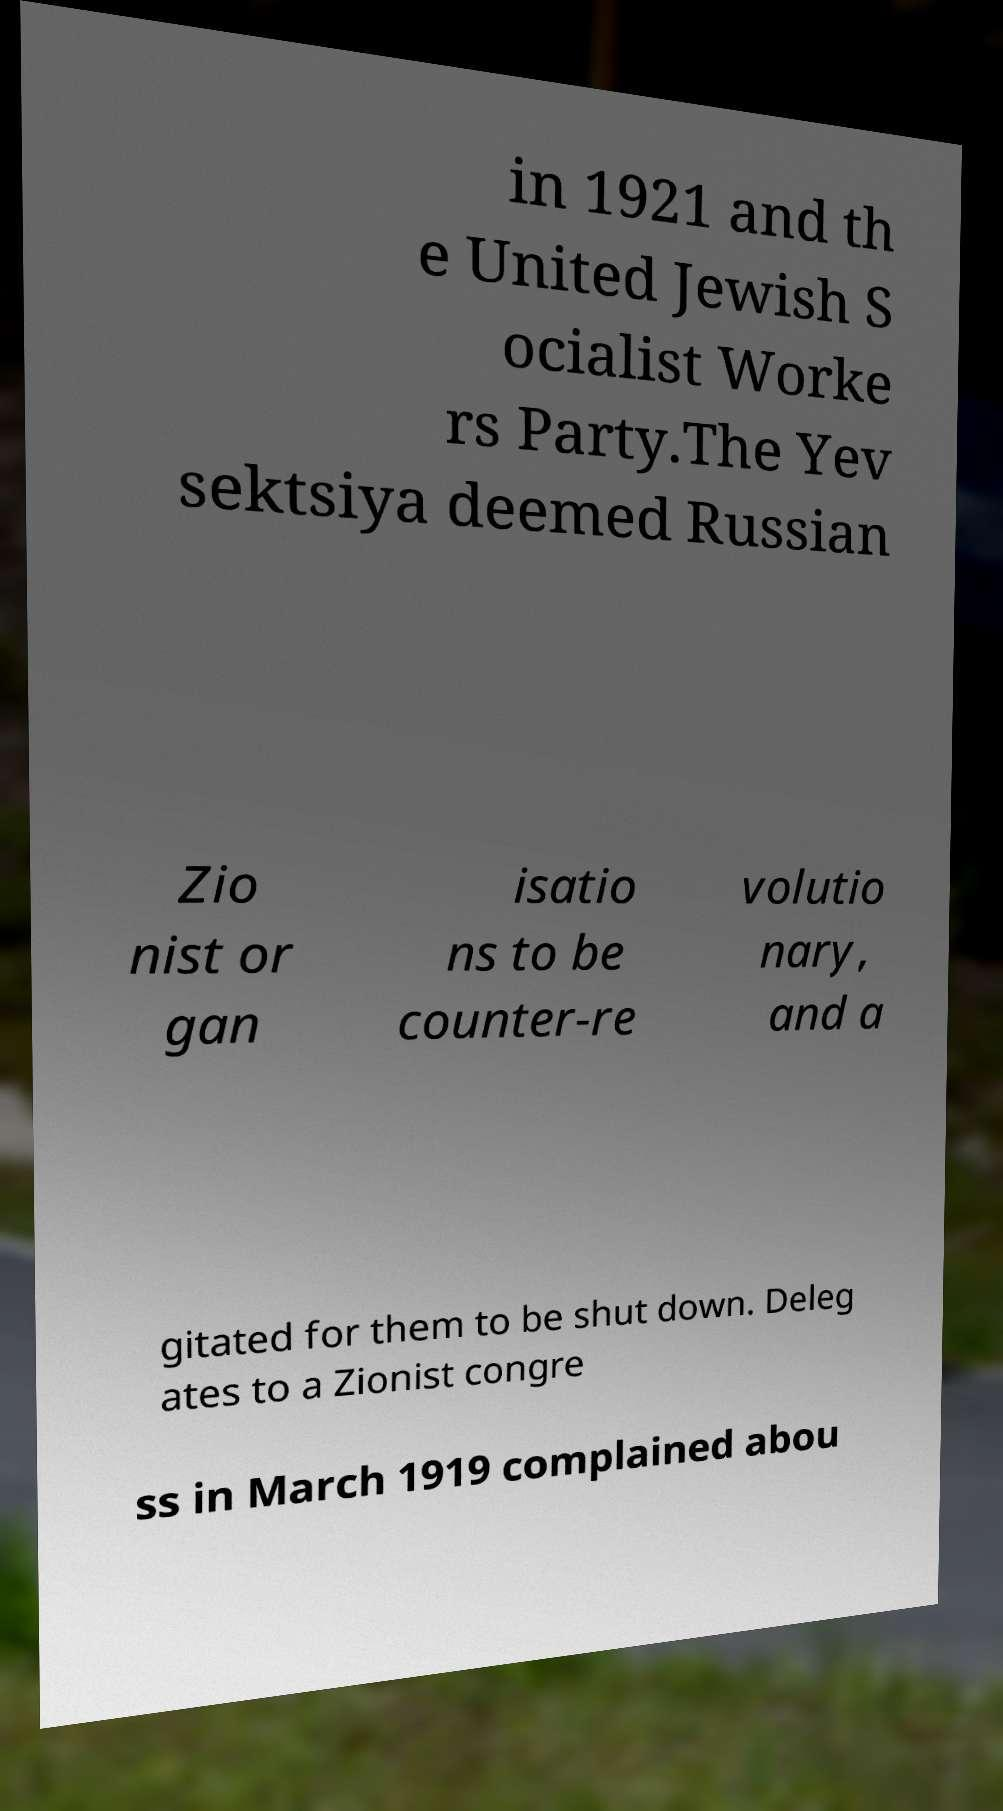For documentation purposes, I need the text within this image transcribed. Could you provide that? in 1921 and th e United Jewish S ocialist Worke rs Party.The Yev sektsiya deemed Russian Zio nist or gan isatio ns to be counter-re volutio nary, and a gitated for them to be shut down. Deleg ates to a Zionist congre ss in March 1919 complained abou 